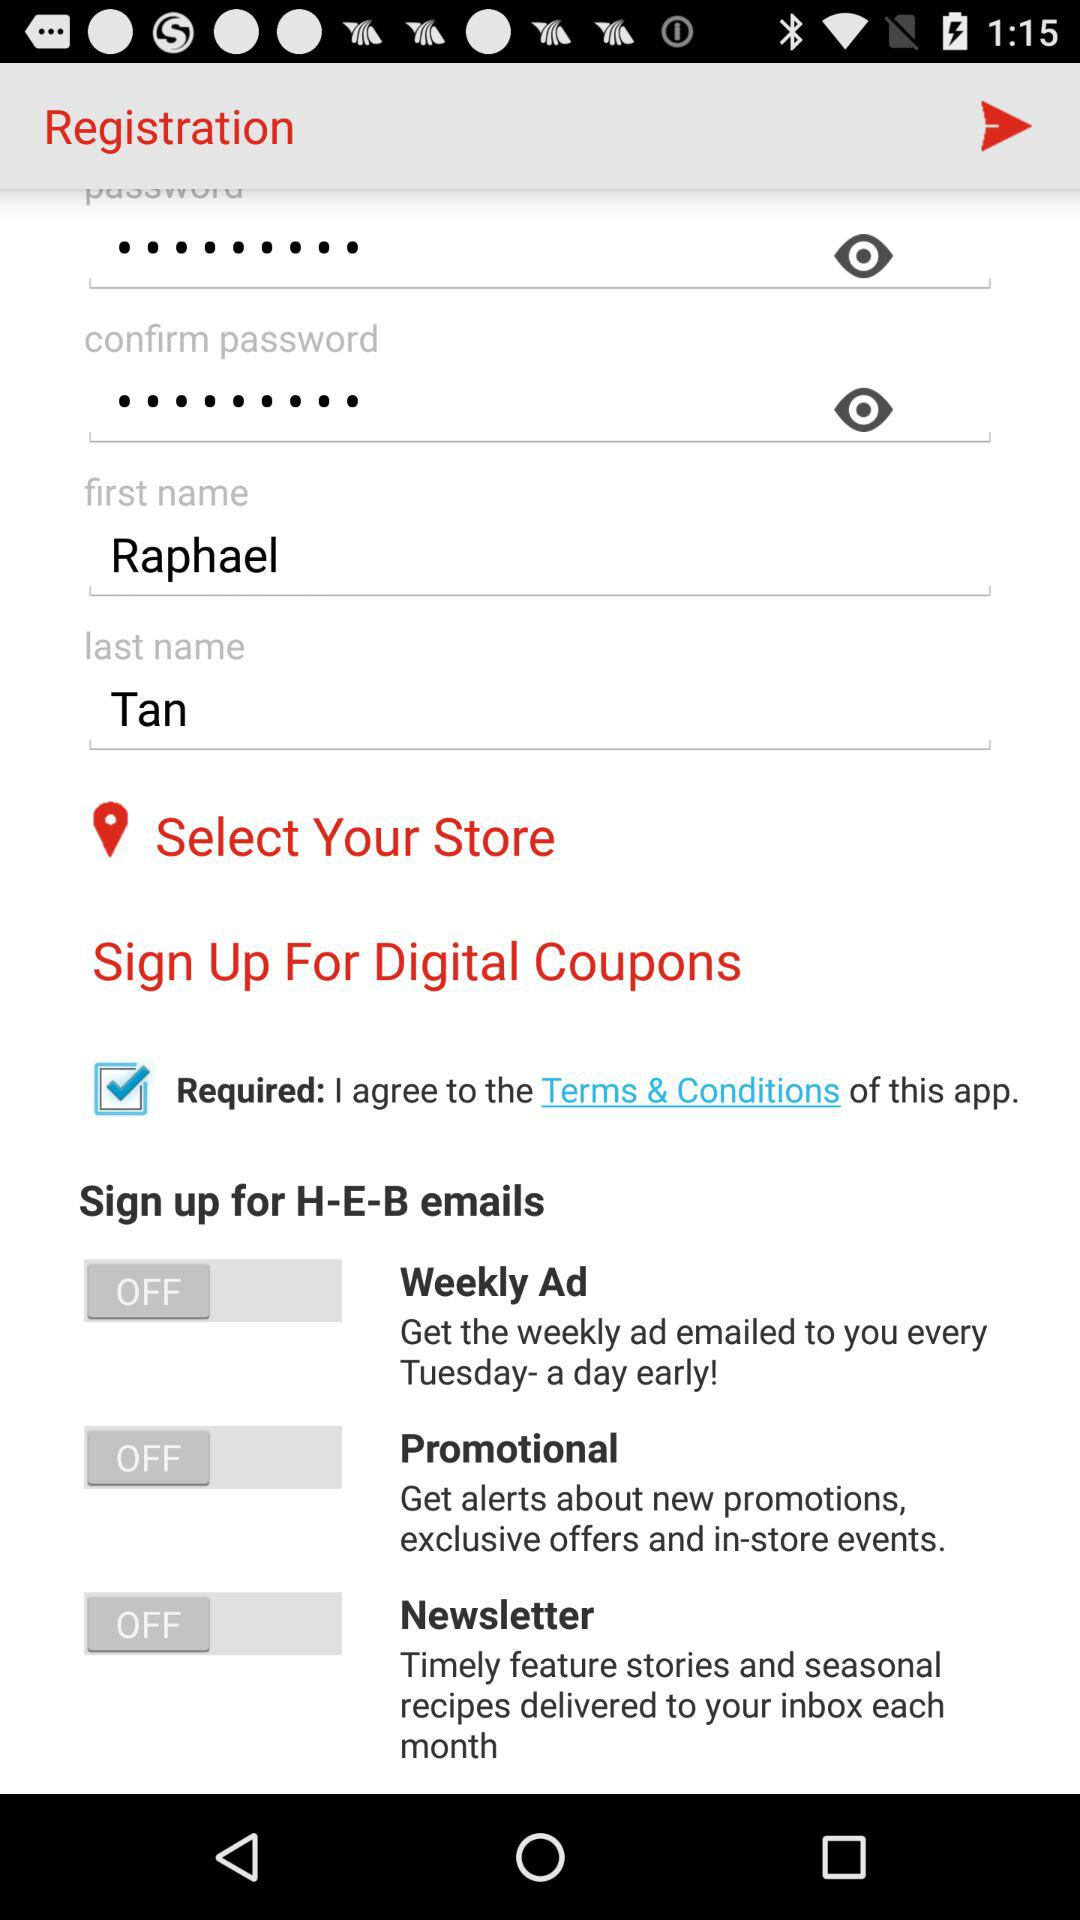What is the first name of the user? The first name of the user is Raphael. 